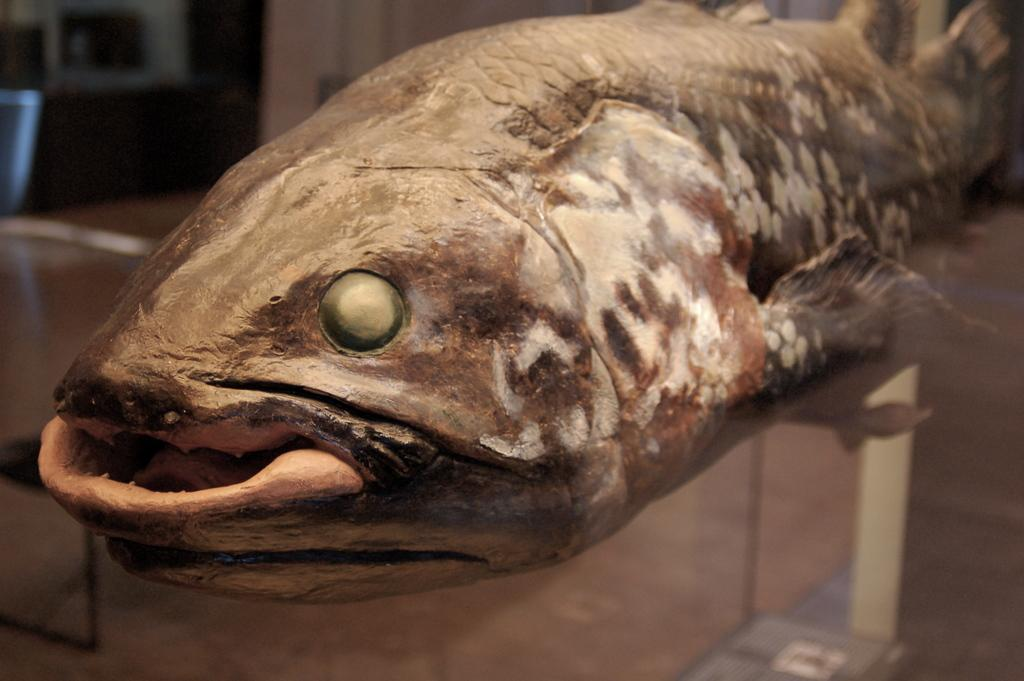What is the main subject of the image? The main subject of the image is a dead fish. What shape is the sack that the fish is trying to touch in the image? There is no sack present in the image, and the fish is dead, so it cannot touch anything. 